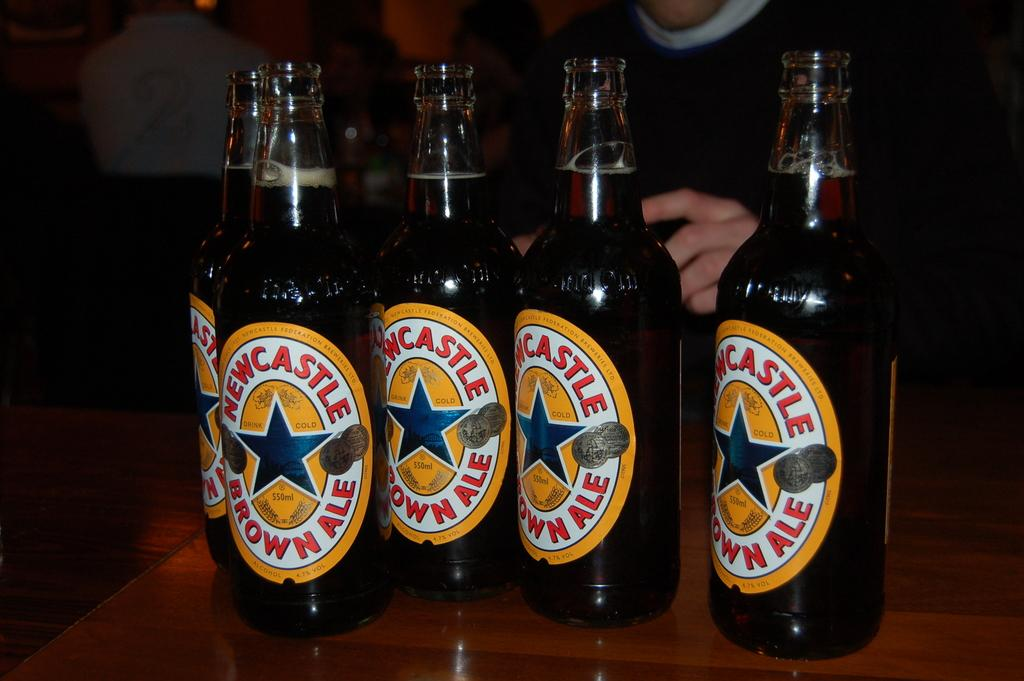<image>
Describe the image concisely. beer bottles that have the place of Newcastle on them 